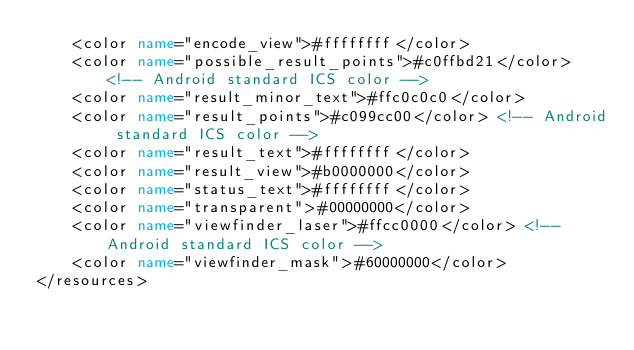<code> <loc_0><loc_0><loc_500><loc_500><_XML_>    <color name="encode_view">#ffffffff</color>
    <color name="possible_result_points">#c0ffbd21</color> <!-- Android standard ICS color -->
    <color name="result_minor_text">#ffc0c0c0</color>
    <color name="result_points">#c099cc00</color> <!-- Android standard ICS color -->
    <color name="result_text">#ffffffff</color>
    <color name="result_view">#b0000000</color>
    <color name="status_text">#ffffffff</color>
    <color name="transparent">#00000000</color>
    <color name="viewfinder_laser">#ffcc0000</color> <!-- Android standard ICS color -->
    <color name="viewfinder_mask">#60000000</color>
</resources>
</code> 